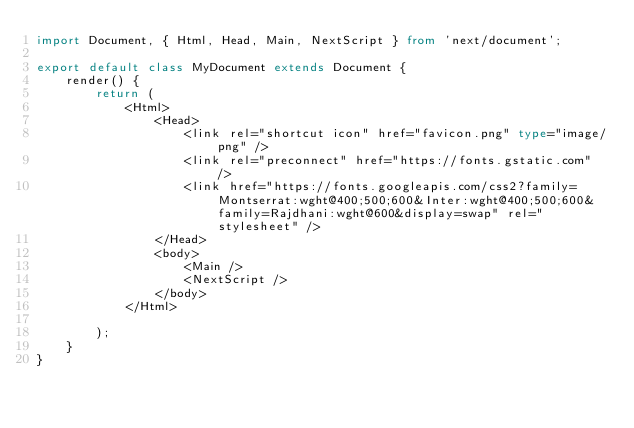<code> <loc_0><loc_0><loc_500><loc_500><_TypeScript_>import Document, { Html, Head, Main, NextScript } from 'next/document';

export default class MyDocument extends Document {
    render() {
        return (
            <Html>
                <Head>
                    <link rel="shortcut icon" href="favicon.png" type="image/png" />
                    <link rel="preconnect" href="https://fonts.gstatic.com" />
                    <link href="https://fonts.googleapis.com/css2?family=Montserrat:wght@400;500;600&Inter:wght@400;500;600&family=Rajdhani:wght@600&display=swap" rel="stylesheet" />
                </Head>
                <body>
                    <Main />
                    <NextScript />
                </body>
            </Html>

        );
    }
}</code> 